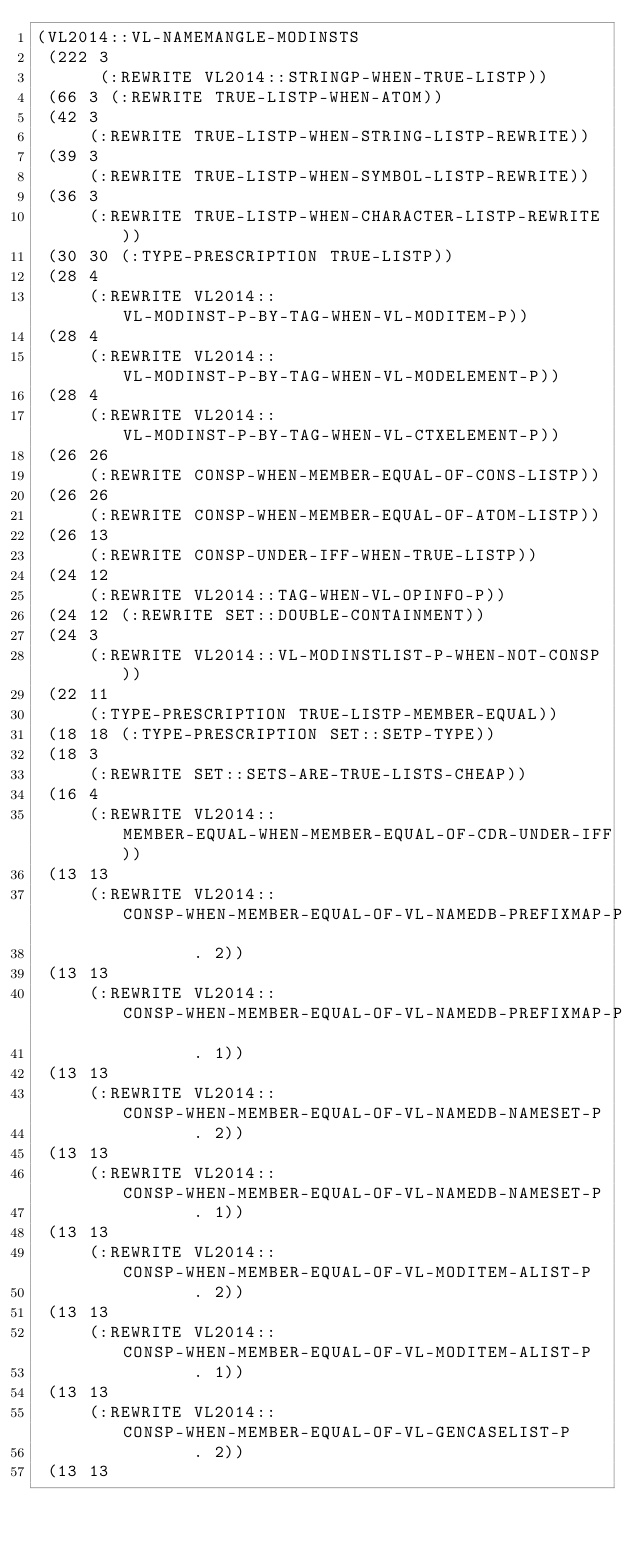<code> <loc_0><loc_0><loc_500><loc_500><_Lisp_>(VL2014::VL-NAMEMANGLE-MODINSTS
 (222 3
      (:REWRITE VL2014::STRINGP-WHEN-TRUE-LISTP))
 (66 3 (:REWRITE TRUE-LISTP-WHEN-ATOM))
 (42 3
     (:REWRITE TRUE-LISTP-WHEN-STRING-LISTP-REWRITE))
 (39 3
     (:REWRITE TRUE-LISTP-WHEN-SYMBOL-LISTP-REWRITE))
 (36 3
     (:REWRITE TRUE-LISTP-WHEN-CHARACTER-LISTP-REWRITE))
 (30 30 (:TYPE-PRESCRIPTION TRUE-LISTP))
 (28 4
     (:REWRITE VL2014::VL-MODINST-P-BY-TAG-WHEN-VL-MODITEM-P))
 (28 4
     (:REWRITE VL2014::VL-MODINST-P-BY-TAG-WHEN-VL-MODELEMENT-P))
 (28 4
     (:REWRITE VL2014::VL-MODINST-P-BY-TAG-WHEN-VL-CTXELEMENT-P))
 (26 26
     (:REWRITE CONSP-WHEN-MEMBER-EQUAL-OF-CONS-LISTP))
 (26 26
     (:REWRITE CONSP-WHEN-MEMBER-EQUAL-OF-ATOM-LISTP))
 (26 13
     (:REWRITE CONSP-UNDER-IFF-WHEN-TRUE-LISTP))
 (24 12
     (:REWRITE VL2014::TAG-WHEN-VL-OPINFO-P))
 (24 12 (:REWRITE SET::DOUBLE-CONTAINMENT))
 (24 3
     (:REWRITE VL2014::VL-MODINSTLIST-P-WHEN-NOT-CONSP))
 (22 11
     (:TYPE-PRESCRIPTION TRUE-LISTP-MEMBER-EQUAL))
 (18 18 (:TYPE-PRESCRIPTION SET::SETP-TYPE))
 (18 3
     (:REWRITE SET::SETS-ARE-TRUE-LISTS-CHEAP))
 (16 4
     (:REWRITE VL2014::MEMBER-EQUAL-WHEN-MEMBER-EQUAL-OF-CDR-UNDER-IFF))
 (13 13
     (:REWRITE VL2014::CONSP-WHEN-MEMBER-EQUAL-OF-VL-NAMEDB-PREFIXMAP-P
               . 2))
 (13 13
     (:REWRITE VL2014::CONSP-WHEN-MEMBER-EQUAL-OF-VL-NAMEDB-PREFIXMAP-P
               . 1))
 (13 13
     (:REWRITE VL2014::CONSP-WHEN-MEMBER-EQUAL-OF-VL-NAMEDB-NAMESET-P
               . 2))
 (13 13
     (:REWRITE VL2014::CONSP-WHEN-MEMBER-EQUAL-OF-VL-NAMEDB-NAMESET-P
               . 1))
 (13 13
     (:REWRITE VL2014::CONSP-WHEN-MEMBER-EQUAL-OF-VL-MODITEM-ALIST-P
               . 2))
 (13 13
     (:REWRITE VL2014::CONSP-WHEN-MEMBER-EQUAL-OF-VL-MODITEM-ALIST-P
               . 1))
 (13 13
     (:REWRITE VL2014::CONSP-WHEN-MEMBER-EQUAL-OF-VL-GENCASELIST-P
               . 2))
 (13 13</code> 